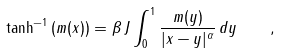<formula> <loc_0><loc_0><loc_500><loc_500>\tanh ^ { - 1 } \left ( m ( x ) \right ) = { \beta \, J } \int _ { 0 } ^ { 1 } \frac { m ( y ) } { | x - y | ^ { \alpha } } \, d y \quad ,</formula> 